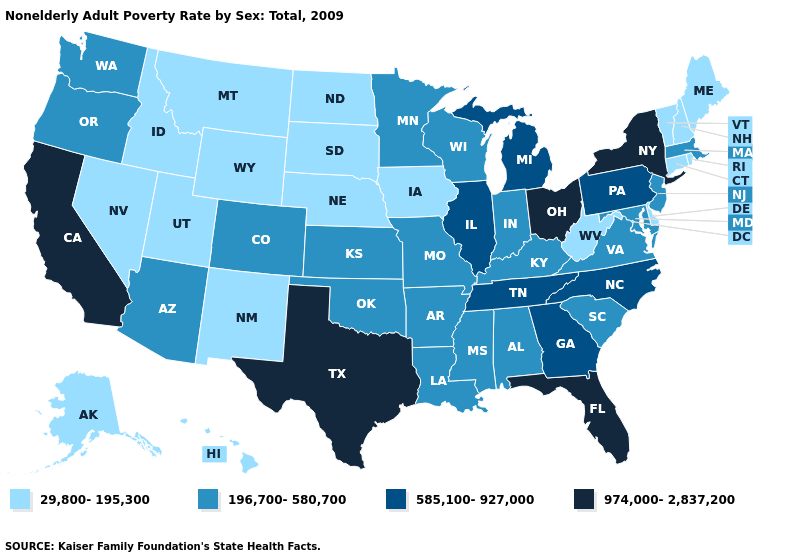What is the value of California?
Answer briefly. 974,000-2,837,200. Is the legend a continuous bar?
Answer briefly. No. Does South Carolina have the same value as Virginia?
Be succinct. Yes. Name the states that have a value in the range 196,700-580,700?
Short answer required. Alabama, Arizona, Arkansas, Colorado, Indiana, Kansas, Kentucky, Louisiana, Maryland, Massachusetts, Minnesota, Mississippi, Missouri, New Jersey, Oklahoma, Oregon, South Carolina, Virginia, Washington, Wisconsin. Which states have the lowest value in the South?
Keep it brief. Delaware, West Virginia. Which states have the lowest value in the West?
Keep it brief. Alaska, Hawaii, Idaho, Montana, Nevada, New Mexico, Utah, Wyoming. Name the states that have a value in the range 29,800-195,300?
Short answer required. Alaska, Connecticut, Delaware, Hawaii, Idaho, Iowa, Maine, Montana, Nebraska, Nevada, New Hampshire, New Mexico, North Dakota, Rhode Island, South Dakota, Utah, Vermont, West Virginia, Wyoming. What is the value of Minnesota?
Concise answer only. 196,700-580,700. Among the states that border South Dakota , which have the highest value?
Concise answer only. Minnesota. Which states have the lowest value in the MidWest?
Quick response, please. Iowa, Nebraska, North Dakota, South Dakota. Name the states that have a value in the range 585,100-927,000?
Write a very short answer. Georgia, Illinois, Michigan, North Carolina, Pennsylvania, Tennessee. What is the value of Missouri?
Be succinct. 196,700-580,700. What is the value of Oklahoma?
Short answer required. 196,700-580,700. Does the map have missing data?
Short answer required. No. 